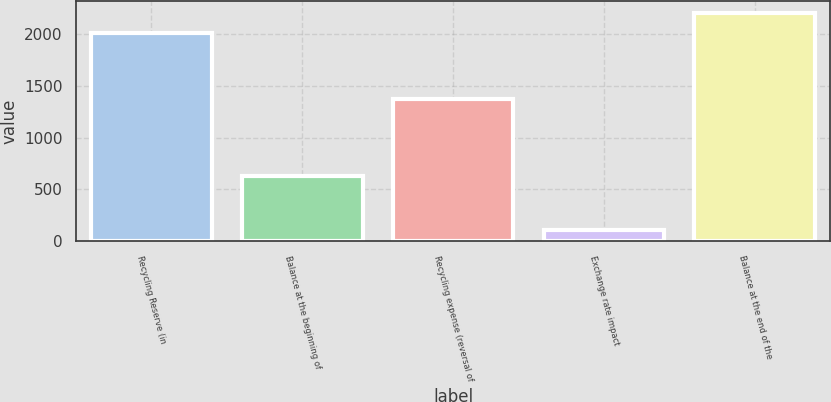<chart> <loc_0><loc_0><loc_500><loc_500><bar_chart><fcel>Recycling Reserve (in<fcel>Balance at the beginning of<fcel>Recycling expense (reversal of<fcel>Exchange rate impact<fcel>Balance at the end of the<nl><fcel>2006<fcel>632<fcel>1373<fcel>110<fcel>2206.5<nl></chart> 